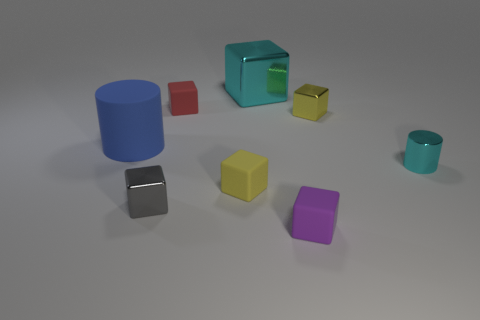Is the color of the metal cylinder the same as the large shiny block?
Offer a terse response. Yes. What is the material of the purple block?
Ensure brevity in your answer.  Rubber. Are there more tiny green metal cubes than cyan metal cylinders?
Make the answer very short. No. Do the red object and the large cyan metal object have the same shape?
Your answer should be compact. Yes. Is there any other thing that is the same shape as the large cyan metallic object?
Your response must be concise. Yes. There is a thing in front of the gray block; is it the same color as the metallic block in front of the tiny yellow matte block?
Provide a succinct answer. No. Are there fewer tiny cyan things on the right side of the small cyan object than cubes to the left of the big blue cylinder?
Keep it short and to the point. No. What shape is the small shiny object to the left of the small red matte object?
Provide a short and direct response. Cube. What material is the object that is the same color as the shiny cylinder?
Your response must be concise. Metal. What number of other objects are the same material as the big blue cylinder?
Offer a terse response. 3. 